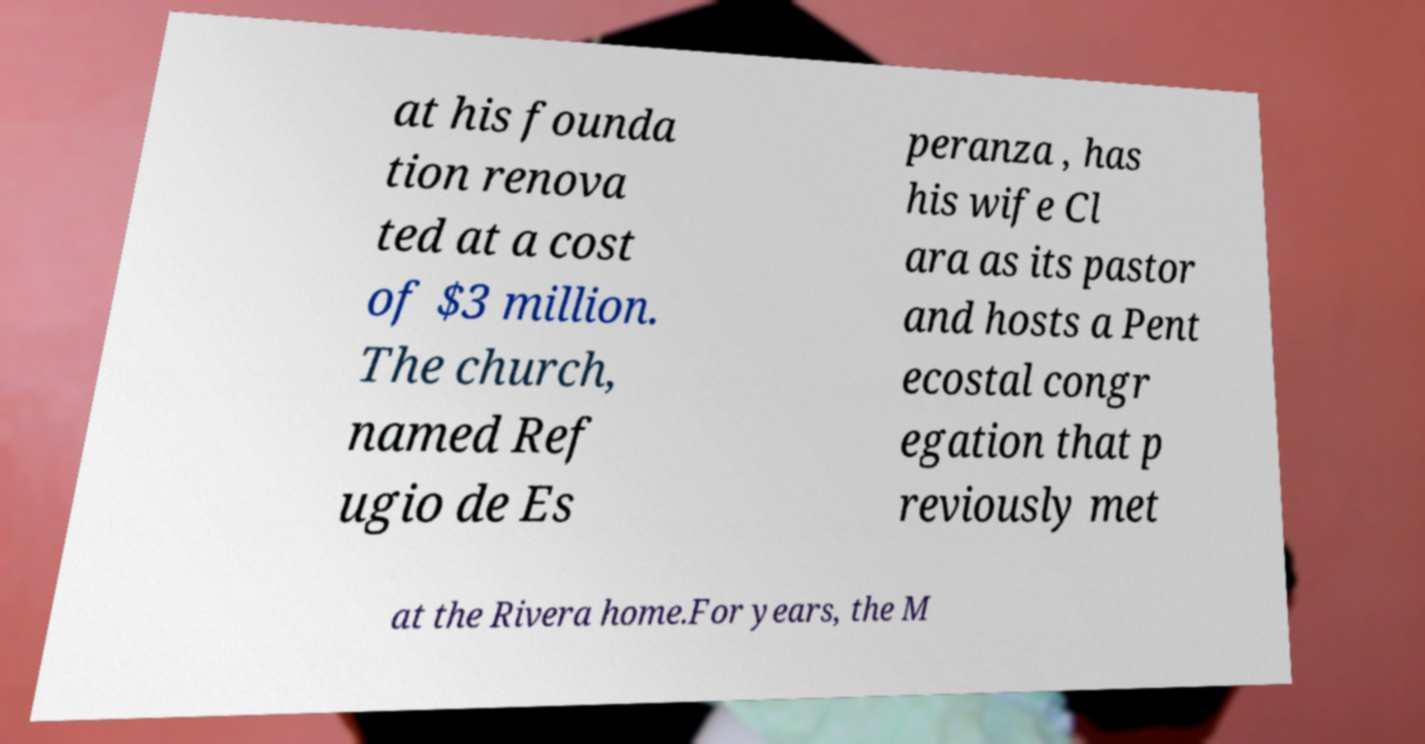For documentation purposes, I need the text within this image transcribed. Could you provide that? at his founda tion renova ted at a cost of $3 million. The church, named Ref ugio de Es peranza , has his wife Cl ara as its pastor and hosts a Pent ecostal congr egation that p reviously met at the Rivera home.For years, the M 